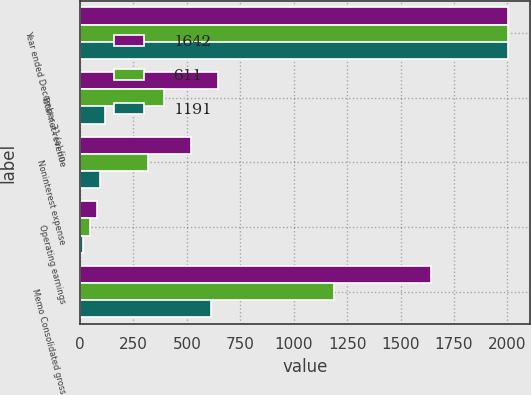<chart> <loc_0><loc_0><loc_500><loc_500><stacked_bar_chart><ecel><fcel>Year ended December 31 (a) (in<fcel>Total net revenue<fcel>Noninterest expense<fcel>Operating earnings<fcel>Memo Consolidated gross<nl><fcel>1642<fcel>2005<fcel>644<fcel>520<fcel>79<fcel>1642<nl><fcel>611<fcel>2004<fcel>393<fcel>317<fcel>48<fcel>1191<nl><fcel>1191<fcel>2003<fcel>115<fcel>92<fcel>13<fcel>611<nl></chart> 